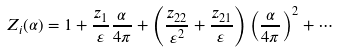Convert formula to latex. <formula><loc_0><loc_0><loc_500><loc_500>Z _ { i } ( \alpha ) = 1 + \frac { z _ { 1 } } { \varepsilon } \frac { \alpha } { 4 \pi } + \left ( \frac { z _ { 2 2 } } { \varepsilon ^ { 2 } } + \frac { z _ { 2 1 } } { \varepsilon } \right ) \left ( \frac { \alpha } { 4 \pi } \right ) ^ { 2 } + \cdots</formula> 